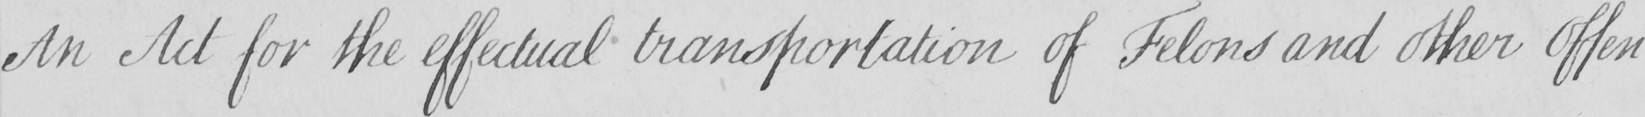Please provide the text content of this handwritten line. An Act for the effectual transportation of Felons and other Offen- 